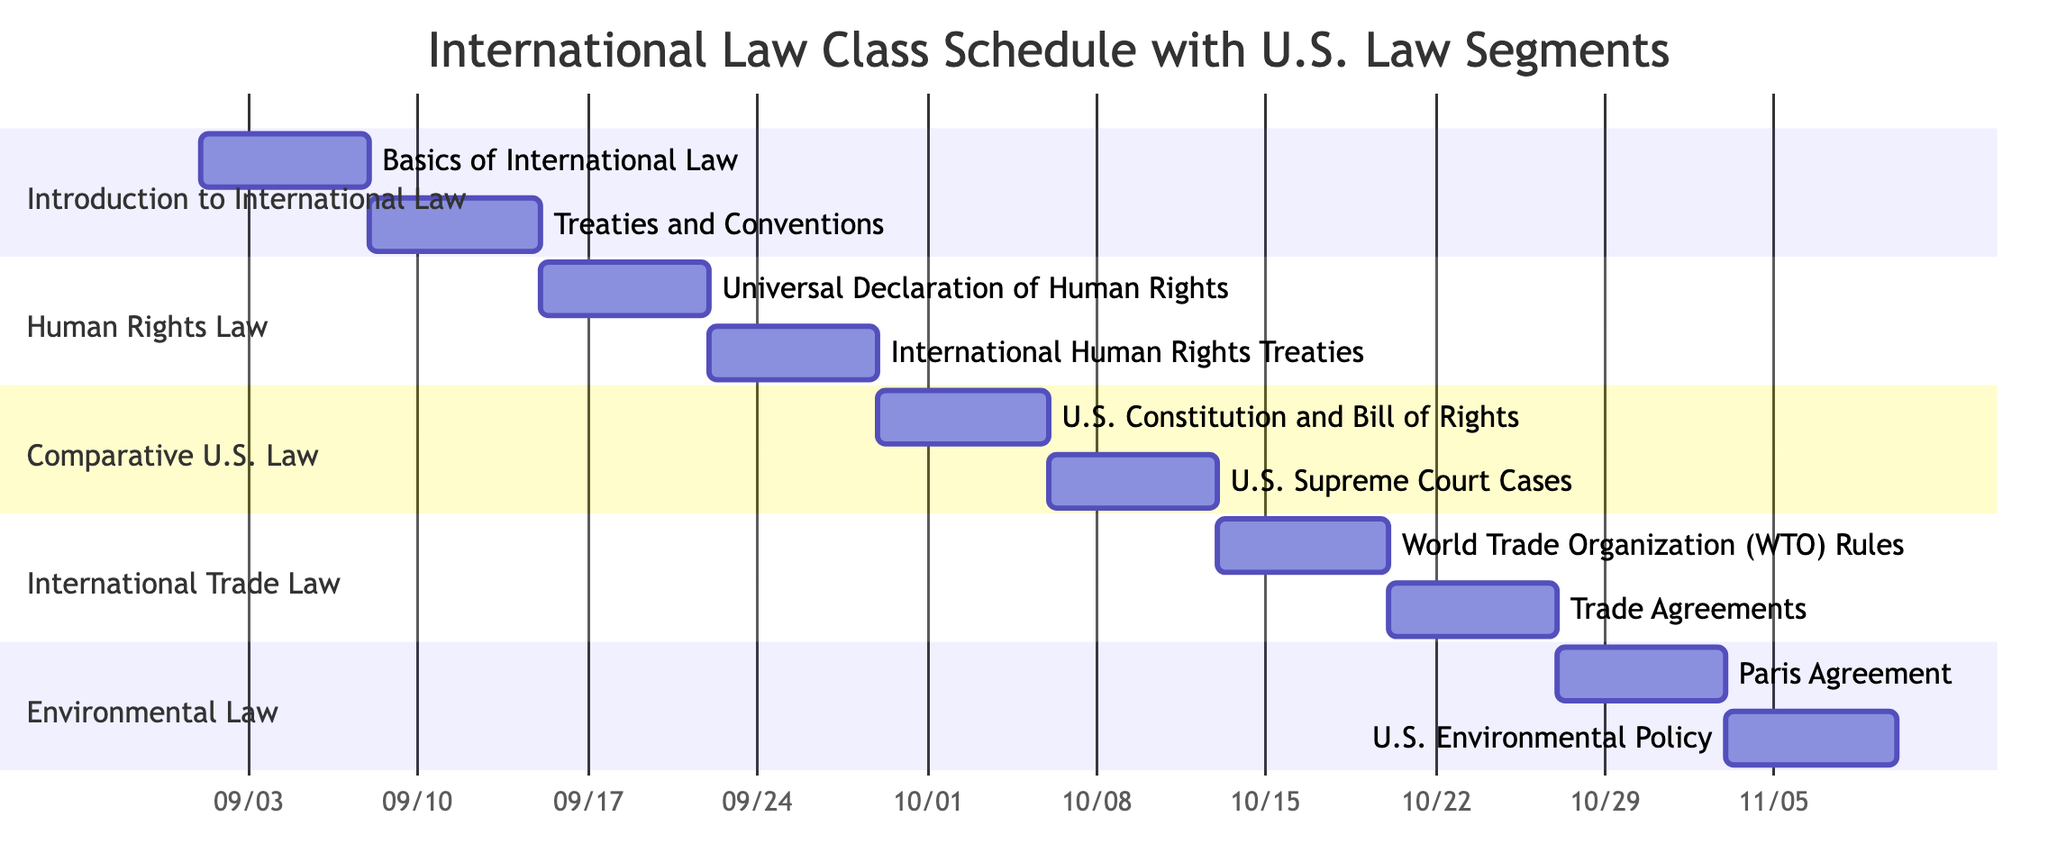What is the start date of the "World Trade Organization (WTO) Rules" topic? The "World Trade Organization (WTO) Rules" topic is listed under the "International Trade Law" section. By following the timeline in the Gantt chart, it starts on 2023-10-13.
Answer: 2023-10-13 How many topics are covered in the "Human Rights Law" course? The "Human Rights Law" course consists of two topics, which are "Universal Declaration of Human Rights" and "International Human Rights Treaties," as indicated in the Gantt chart.
Answer: 2 What is the end date of the "U.S. Constitution and Bill of Rights" topic? The "U.S. Constitution and Bill of Rights" topic is part of the "Comparative U.S. Law" course. According to the Gantt chart, its end date is 2023-10-05, which can be observed from the timeline.
Answer: 2023-10-05 Which course starts on the latest date? To determine which course starts latest, we can look for the course with the most recent start date in the Gantt chart. "Environmental Law" commences on 2023-10-27, which is later than all other courses.
Answer: Environmental Law What is the total duration of the "International Trade Law" section? The "International Trade Law" section comprises two topics: "World Trade Organization (WTO) Rules" and "Trade Agreements." Each topic lasts 7 days, so to find the total duration, we count 14 days, from the start date of the first topic to the end date of the second.
Answer: 14 days Which topic overlaps with the "U.S. Environmental Policy" topic? The "U.S. Environmental Policy" topic runs from 2023-11-03 to 2023-11-09. The preceding topic "Paris Agreement" runs from 2023-10-27 to 2023-11-02, indicating that there is no overlap; there are no topics overlapping it. There is an overlap with the duration of International Human Rights Treaties from the previous course.
Answer: No overlap What is the sequence of courses leading up to "U.S. Environmental Policy"? To identify the sequence of courses leading to the "U.S. Environmental Policy," we trace backwards from that topic: it follows "Paris Agreement," which is the last topic of the "Environmental Law" course, and precedes it are the "International Trade Law" and "Comparative U.S. Law" courses. Thus the sequence is: Environmental Law -> International Trade Law -> Comparative U.S. Law.
Answer: Environmental Law -> International Trade Law -> Comparative U.S. Law 